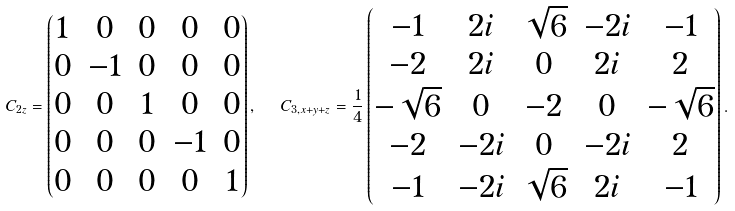<formula> <loc_0><loc_0><loc_500><loc_500>C _ { 2 z } = \begin{pmatrix} 1 & 0 & 0 & 0 & 0 \\ 0 & - 1 & 0 & 0 & 0 \\ 0 & 0 & 1 & 0 & 0 \\ 0 & 0 & 0 & - 1 & 0 \\ 0 & 0 & 0 & 0 & 1 \end{pmatrix} , \ \ C _ { 3 , x + y + z } = \frac { 1 } { 4 } \begin{pmatrix} - 1 & 2 i & \sqrt { 6 } & - 2 i & - 1 \\ - 2 & 2 i & 0 & 2 i & 2 \\ - \sqrt { 6 } & 0 & - 2 & 0 & - \sqrt { 6 } \\ - 2 & - 2 i & 0 & - 2 i & 2 \\ - 1 & - 2 i & \sqrt { 6 } & 2 i & - 1 \end{pmatrix} .</formula> 